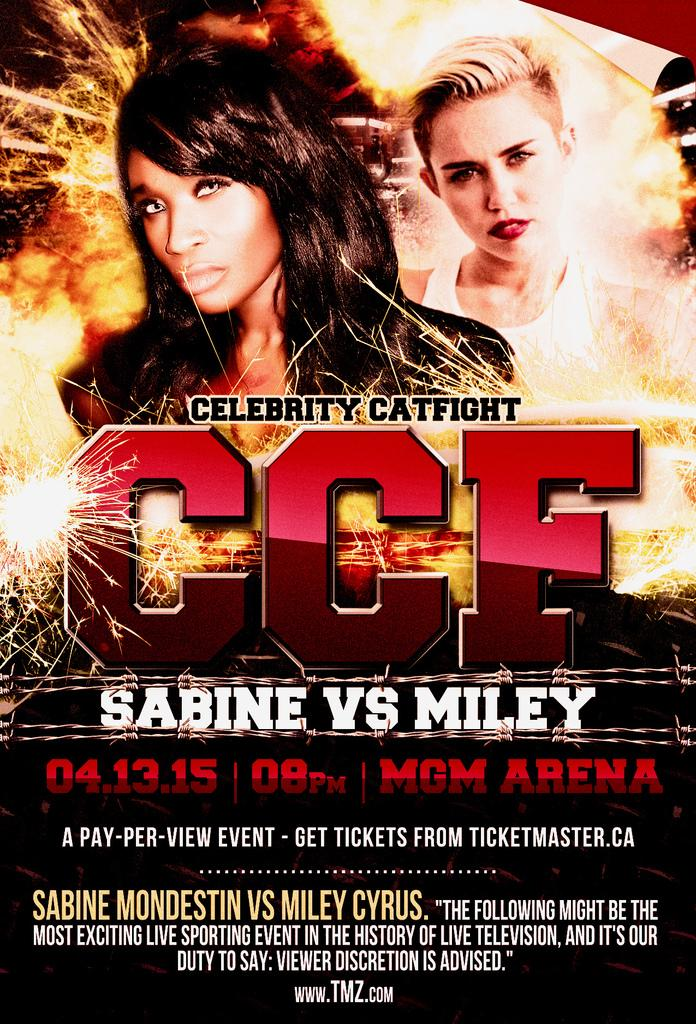<image>
Share a concise interpretation of the image provided. Miley and Sabine will fight in an arena. 